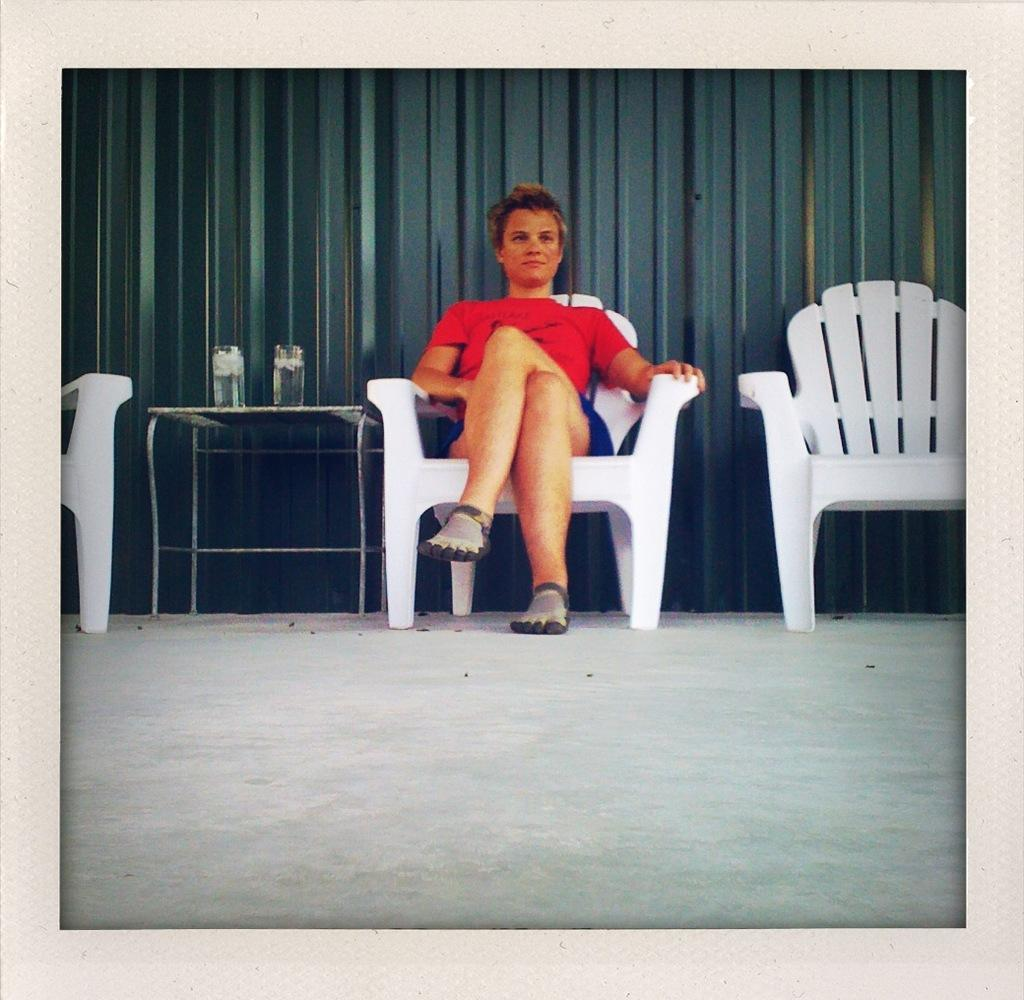What is the person in the image doing? The person is sitting on a chair in the image. How many chairs are visible in the image? There are chairs in the image. What is on the table in the image? There is a glass on the table in the image. What can be seen in the background of the image? There is a curtain in the background. What story is the person reading from the table in the image? There is no story or book visible in the image; only a glass is present on the table. 